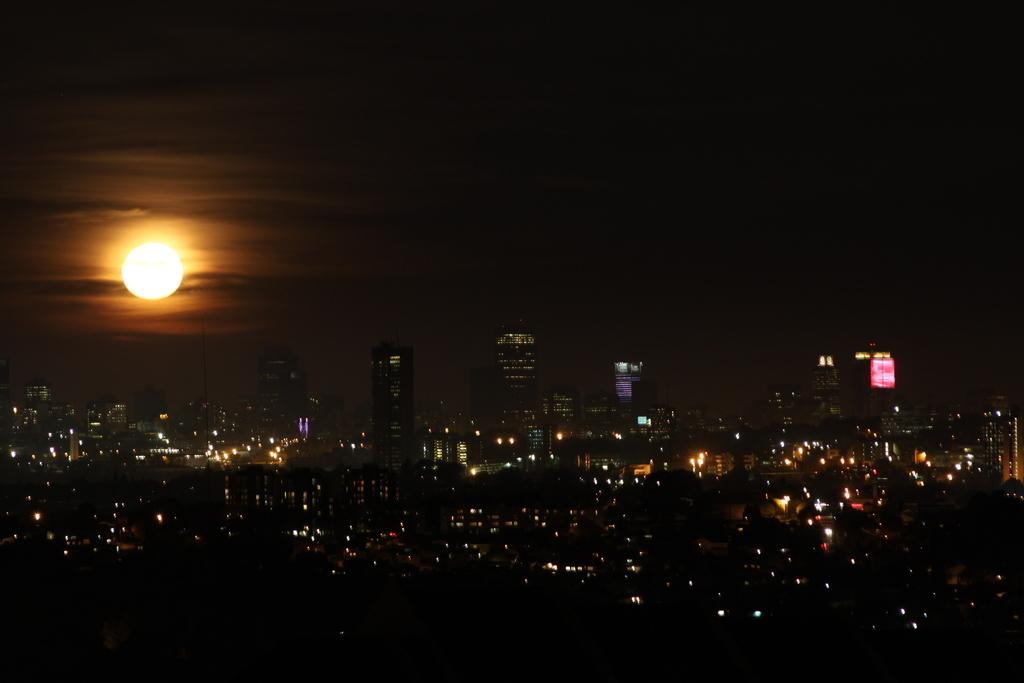What type of structures can be seen in the image? There are buildings in the image. What can be seen illuminating the scene in the image? There are lights visible in the image. What celestial body is present in the image? The moon is present in the image. What is the color of the sky in the image? The sky is dark in color. What decision was made by the secretary in the image? There is no secretary present in the image, so no decision can be attributed to them. 